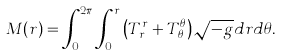<formula> <loc_0><loc_0><loc_500><loc_500>M ( r ) = \int _ { 0 } ^ { 2 \pi } \int _ { 0 } ^ { r } \left ( T ^ { r } _ { \, r } + T ^ { \theta } _ { \, \theta } \right ) \sqrt { - g } d r d \theta .</formula> 